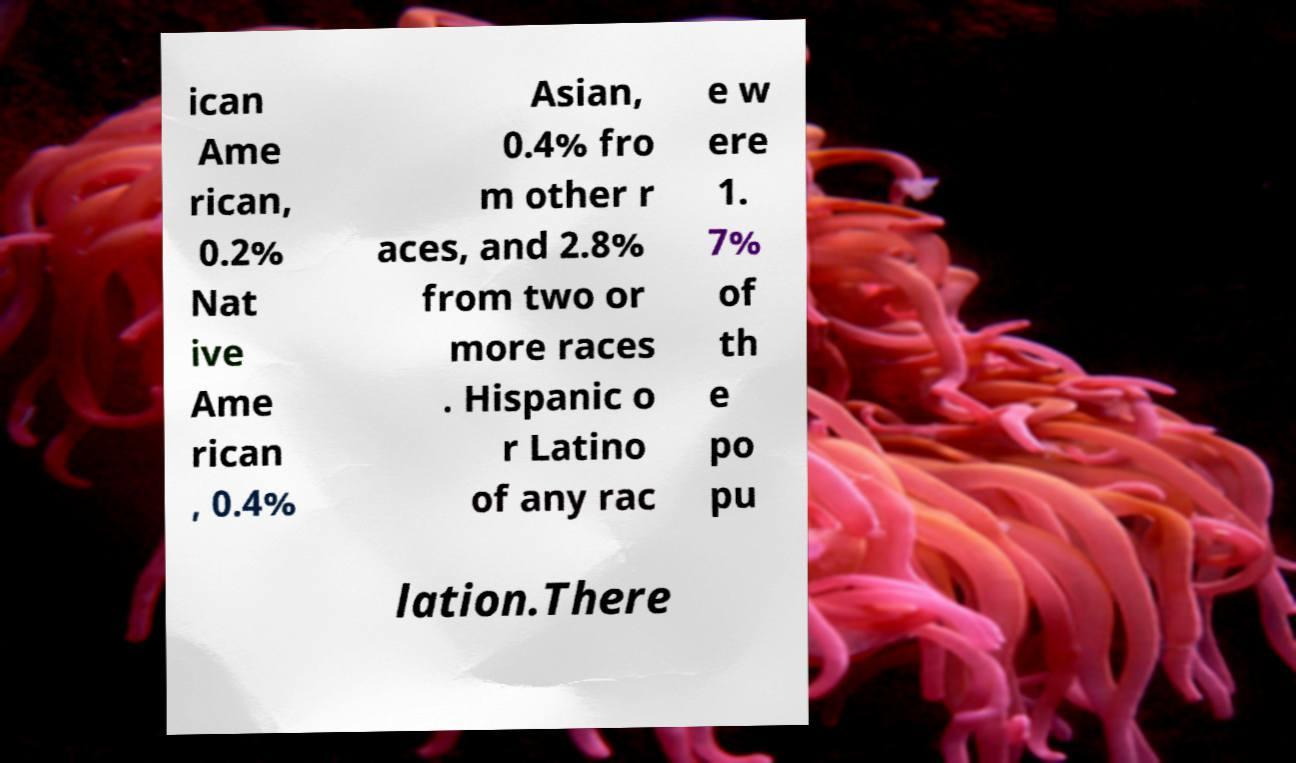For documentation purposes, I need the text within this image transcribed. Could you provide that? ican Ame rican, 0.2% Nat ive Ame rican , 0.4% Asian, 0.4% fro m other r aces, and 2.8% from two or more races . Hispanic o r Latino of any rac e w ere 1. 7% of th e po pu lation.There 